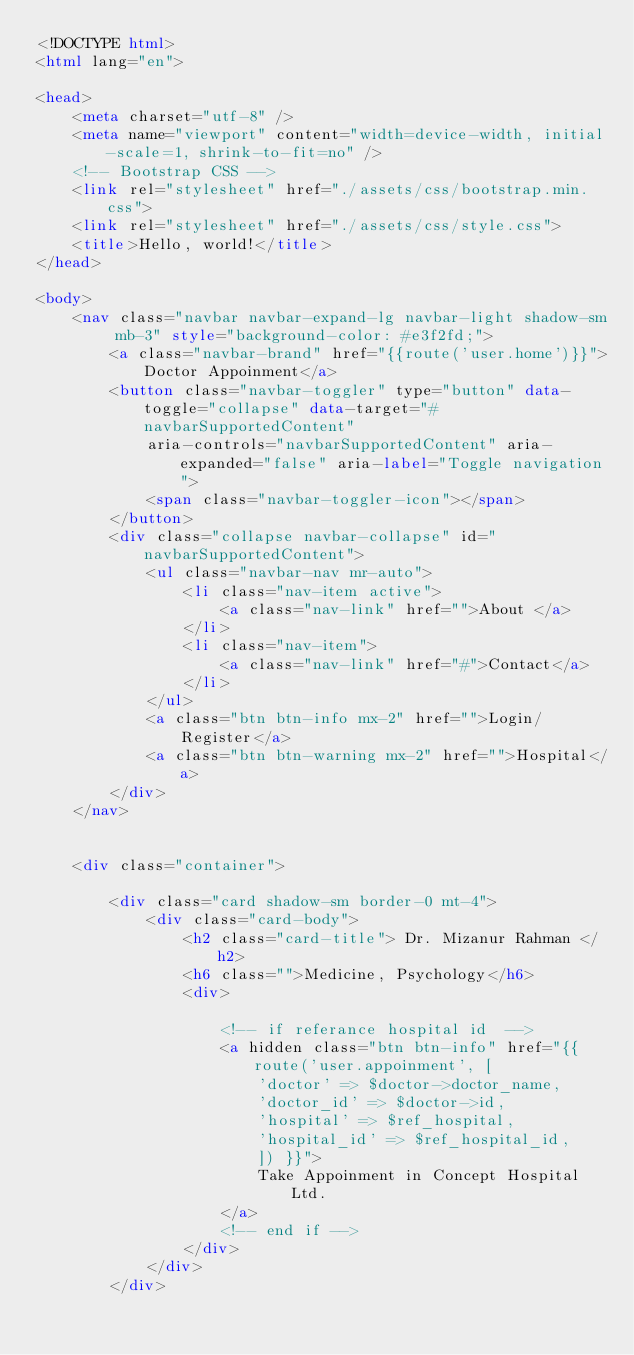<code> <loc_0><loc_0><loc_500><loc_500><_HTML_><!DOCTYPE html>
<html lang="en">

<head>
    <meta charset="utf-8" />
    <meta name="viewport" content="width=device-width, initial-scale=1, shrink-to-fit=no" />
    <!-- Bootstrap CSS -->
    <link rel="stylesheet" href="./assets/css/bootstrap.min.css">
    <link rel="stylesheet" href="./assets/css/style.css">
    <title>Hello, world!</title>
</head>

<body>
    <nav class="navbar navbar-expand-lg navbar-light shadow-sm mb-3" style="background-color: #e3f2fd;">
        <a class="navbar-brand" href="{{route('user.home')}}">Doctor Appoinment</a>
        <button class="navbar-toggler" type="button" data-toggle="collapse" data-target="#navbarSupportedContent"
            aria-controls="navbarSupportedContent" aria-expanded="false" aria-label="Toggle navigation">
            <span class="navbar-toggler-icon"></span>
        </button>
        <div class="collapse navbar-collapse" id="navbarSupportedContent">
            <ul class="navbar-nav mr-auto">
                <li class="nav-item active">
                    <a class="nav-link" href="">About </a>
                </li>
                <li class="nav-item">
                    <a class="nav-link" href="#">Contact</a>
                </li>
            </ul>
            <a class="btn btn-info mx-2" href="">Login/Register</a>
            <a class="btn btn-warning mx-2" href="">Hospital</a>
        </div>
    </nav>


    <div class="container">

        <div class="card shadow-sm border-0 mt-4">
            <div class="card-body">
                <h2 class="card-title"> Dr. Mizanur Rahman </h2>
                <h6 class="">Medicine, Psychology</h6>
                <div>

                    <!-- if referance hospital id  -->
                    <a hidden class="btn btn-info" href="{{ route('user.appoinment', [
                        'doctor' => $doctor->doctor_name,
                        'doctor_id' => $doctor->id,
                        'hospital' => $ref_hospital,
                        'hospital_id' => $ref_hospital_id,
                        ]) }}">
                        Take Appoinment in Concept Hospital Ltd.
                    </a>
                    <!-- end if -->
                </div>
            </div>
        </div>
</code> 